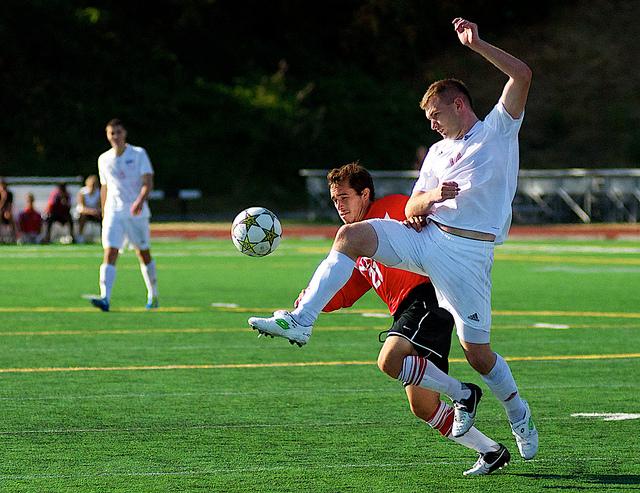How many people are wearing a red shirt?
Quick response, please. 1. Are these people athletic?
Be succinct. Yes. Are both these men on the same team?
Keep it brief. No. Do the soccer players look competitive?
Keep it brief. Yes. 